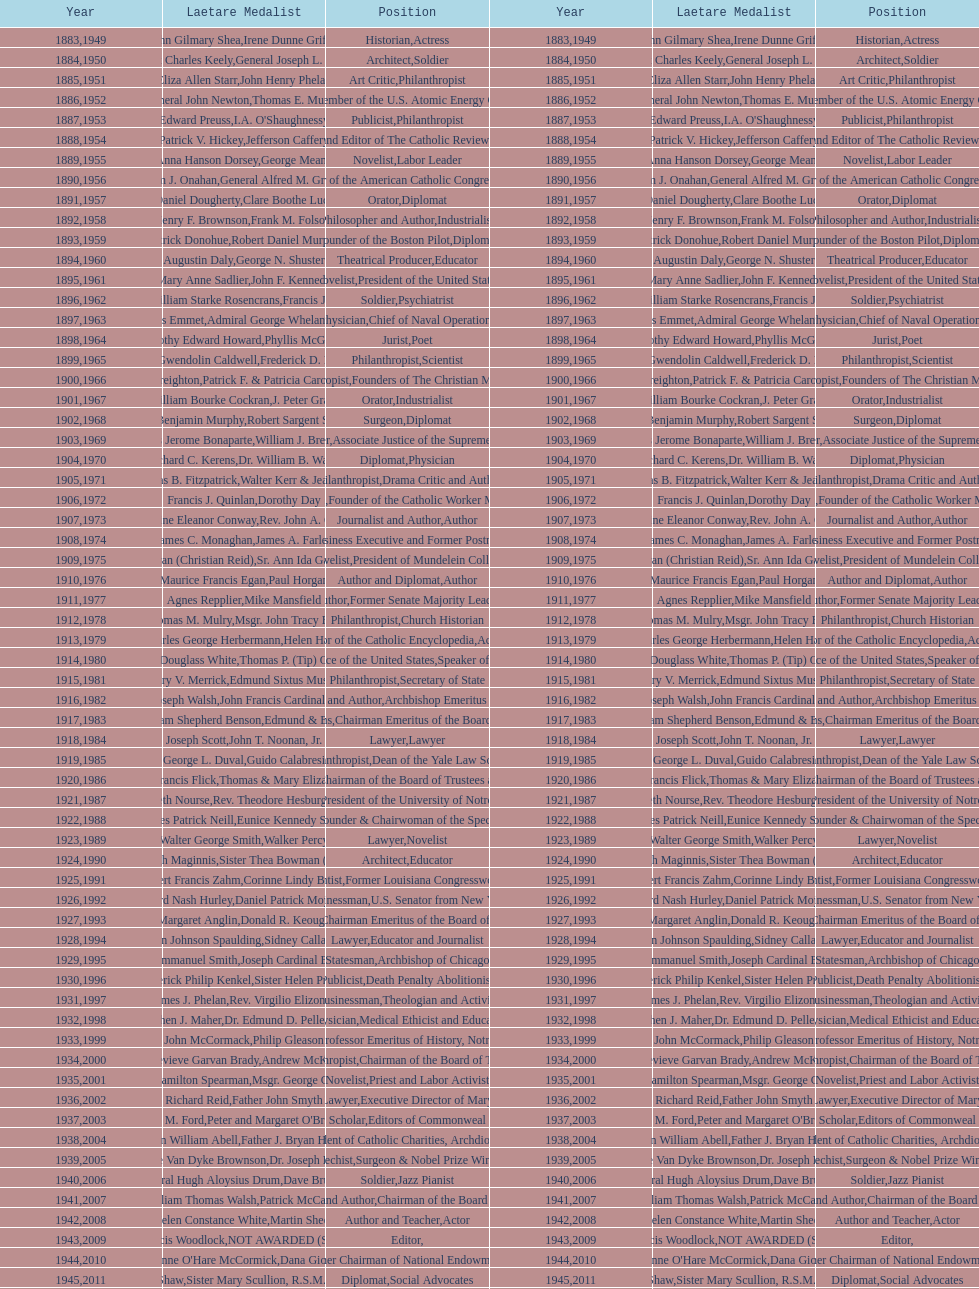Which individual has been awarded both this medal and the nobel prize? Dr. Joseph E. Murray. 